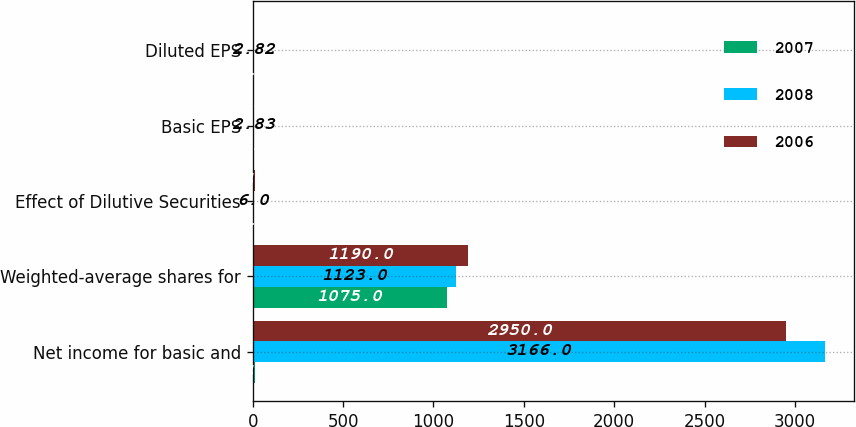Convert chart. <chart><loc_0><loc_0><loc_500><loc_500><stacked_bar_chart><ecel><fcel>Net income for basic and<fcel>Weighted-average shares for<fcel>Effect of Dilutive Securities<fcel>Basic EPS<fcel>Diluted EPS<nl><fcel>2007<fcel>14<fcel>1075<fcel>5<fcel>3.92<fcel>3.9<nl><fcel>2008<fcel>3166<fcel>1123<fcel>6<fcel>2.83<fcel>2.82<nl><fcel>2006<fcel>2950<fcel>1190<fcel>14<fcel>2.51<fcel>2.48<nl></chart> 